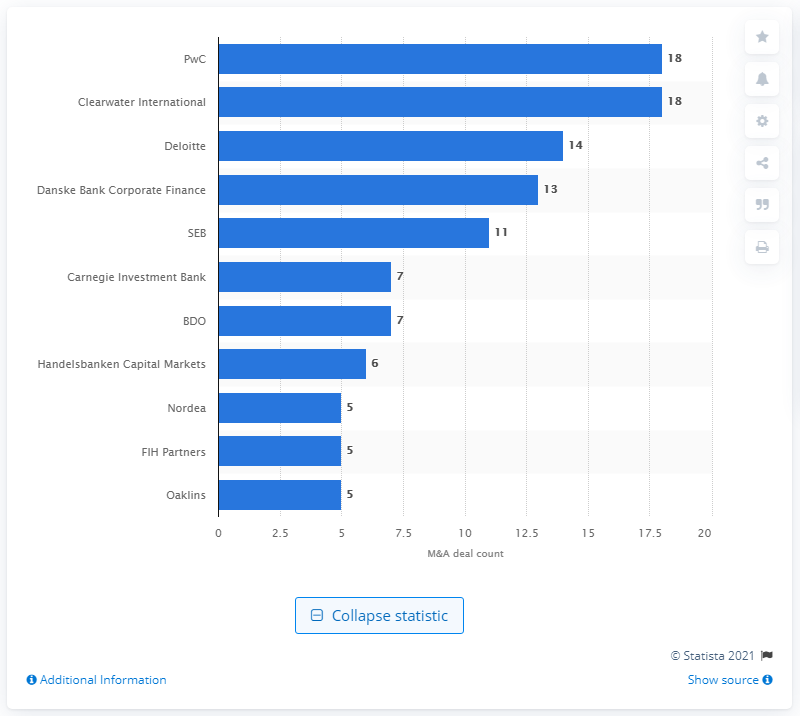Give some essential details in this illustration. In 2016, PwC and Clearwater International jointly closed 18 deals in Denmark. 